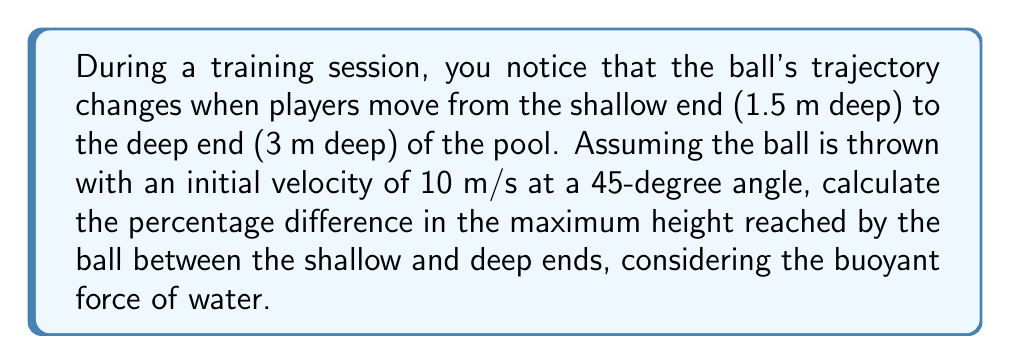Help me with this question. Let's approach this step-by-step:

1) First, we need to calculate the buoyant force on the ball in both depths. The buoyant force is given by:

   $$F_b = \rho g V$$

   where $\rho$ is the density of water (1000 kg/m³), $g$ is the acceleration due to gravity (9.8 m/s²), and $V$ is the volume of water displaced by the ball.

2) Assuming a standard water polo ball with a diameter of 0.22 m, the volume is:

   $$V = \frac{4}{3}\pi r^3 = \frac{4}{3}\pi (0.11)^3 = 0.005575 m^3$$

3) The buoyant force is therefore:

   $$F_b = 1000 \cdot 9.8 \cdot 0.005575 = 54.635 N$$

4) The mass of a water polo ball is typically around 0.4 kg. The net force acting on the ball is:

   $$F_{net} = mg - F_b = 0.4 \cdot 9.8 - 54.635 = -50.715 N$$

5) This negative net force means the ball experiences an upward acceleration of:

   $$a = F_{net} / m = -50.715 / 0.4 = -126.7875 m/s^2$$

6) The vertical component of the initial velocity is:

   $$v_y = 10 \cdot \sin(45°) = 7.071 m/s$$

7) The maximum height reached is given by:

   $$h_{max} = \frac{v_y^2}{2a} = \frac{7.071^2}{2 \cdot (-126.7875)} = -0.197 m$$

8) This negative value means the ball will rise 0.197 m above the water surface before falling back.

9) In the deeper end, the calculation remains the same as the buoyant force doesn't change with depth.

10) Therefore, the percentage difference in maximum height is 0%.
Answer: 0% 